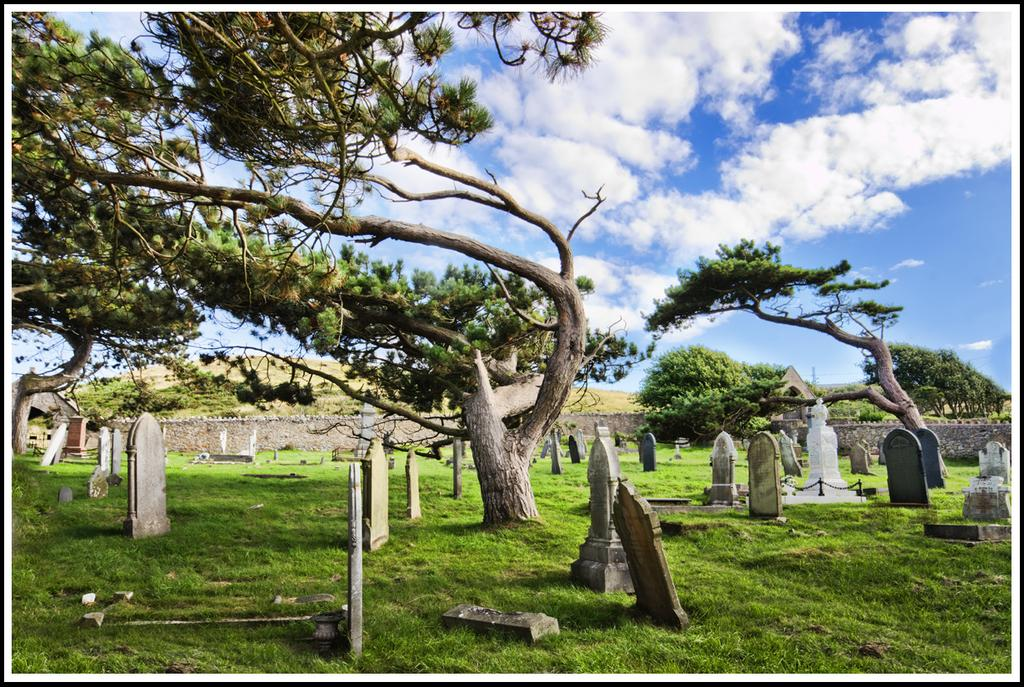What type of vegetation is present in the image? There is grass in the image. What other natural elements can be seen in the image? There are trees in the image. What is the purpose of the graves in the image? The graves in the image are likely for burial and commemoration purposes. What can be seen in the background of the image? There are clouds visible in the background of the image. What type of cork can be seen floating in the image? There is no cork present in the image. How many flies can be seen buzzing around the trees in the image? There are no flies visible in the image. 